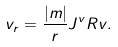Convert formula to latex. <formula><loc_0><loc_0><loc_500><loc_500>v _ { r } = \frac { | m | } { r } J ^ { v } R v .</formula> 